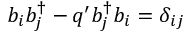<formula> <loc_0><loc_0><loc_500><loc_500>b _ { i } b _ { j } ^ { \dagger } - q ^ { \prime } b _ { j } ^ { \dagger } b _ { i } = \delta _ { i j }</formula> 